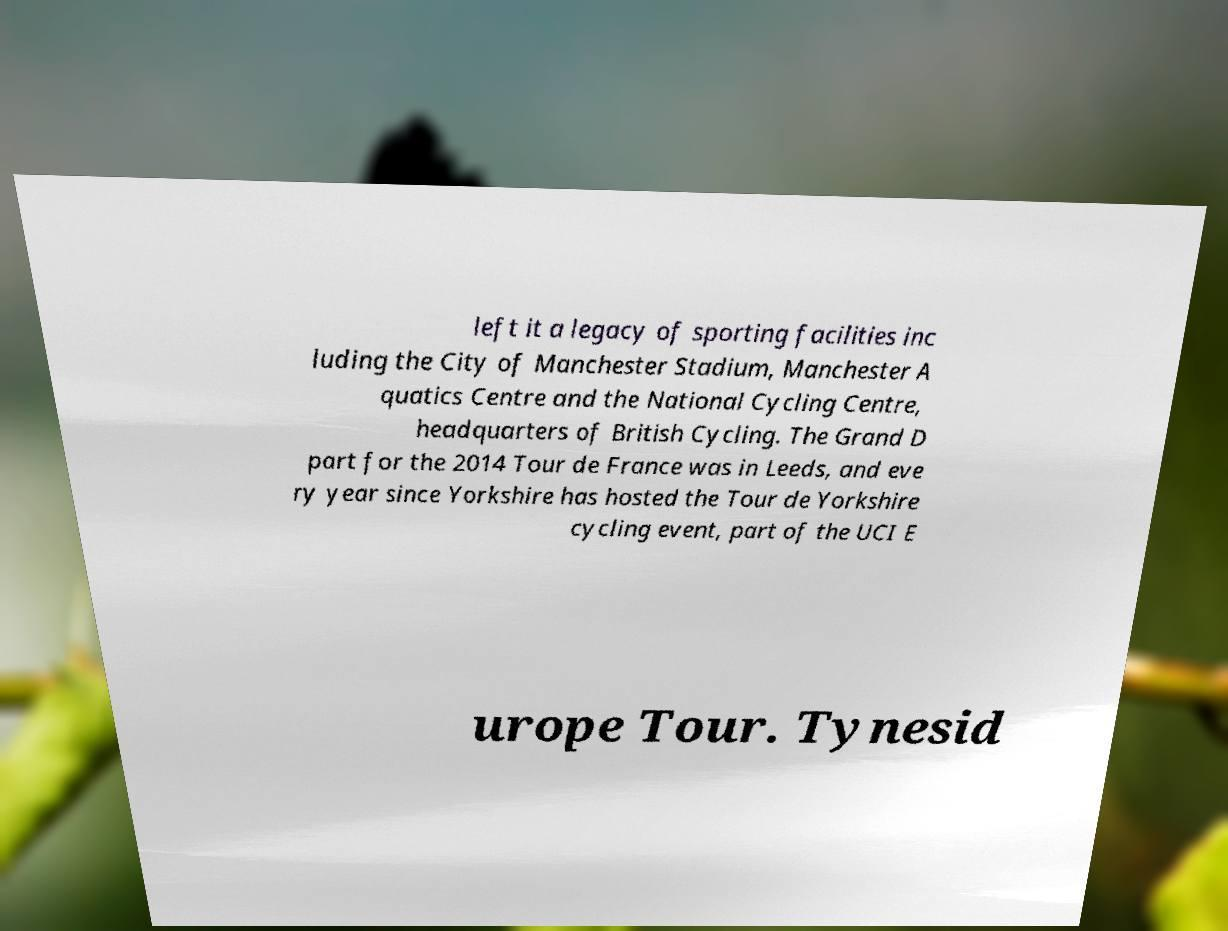I need the written content from this picture converted into text. Can you do that? left it a legacy of sporting facilities inc luding the City of Manchester Stadium, Manchester A quatics Centre and the National Cycling Centre, headquarters of British Cycling. The Grand D part for the 2014 Tour de France was in Leeds, and eve ry year since Yorkshire has hosted the Tour de Yorkshire cycling event, part of the UCI E urope Tour. Tynesid 